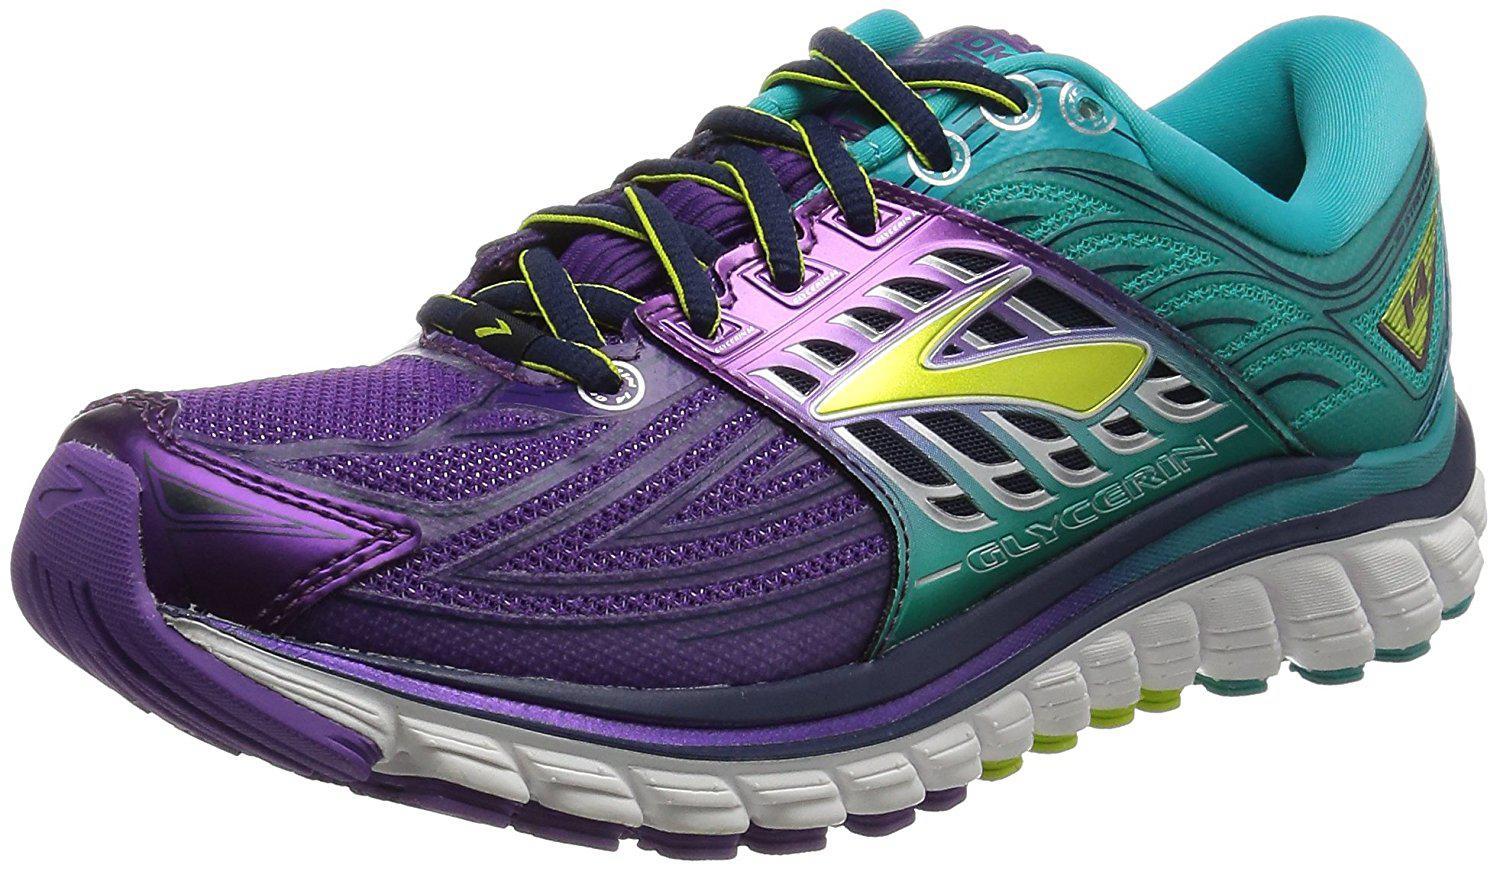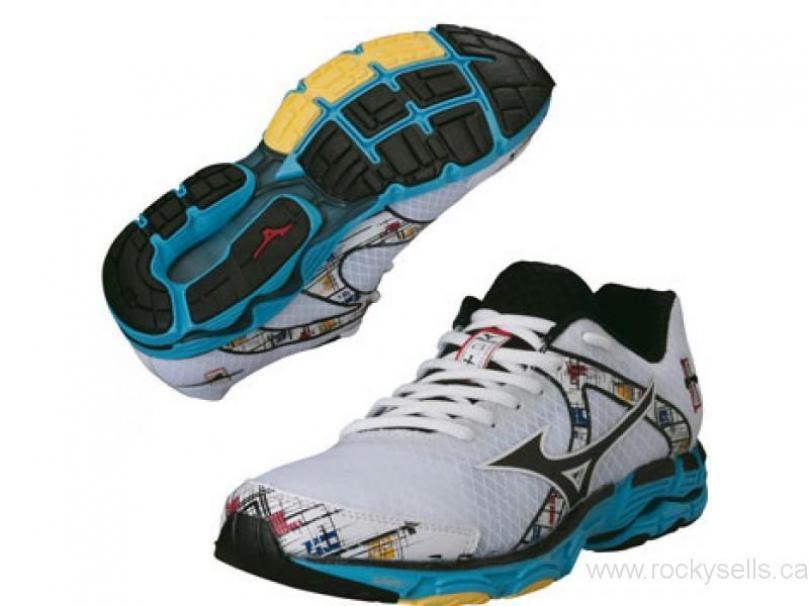The first image is the image on the left, the second image is the image on the right. Evaluate the accuracy of this statement regarding the images: "At least one sneaker incorporates purple in its design.". Is it true? Answer yes or no. Yes. The first image is the image on the left, the second image is the image on the right. Given the left and right images, does the statement "Exactly three shoes are shown, a pair in one image with one turned over with visible sole treads, while a single shoe in the other image is a different color scheme and design." hold true? Answer yes or no. Yes. 